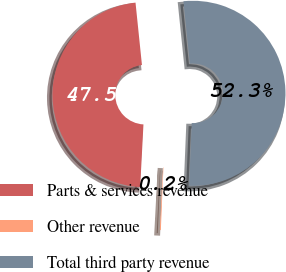Convert chart to OTSL. <chart><loc_0><loc_0><loc_500><loc_500><pie_chart><fcel>Parts & services revenue<fcel>Other revenue<fcel>Total third party revenue<nl><fcel>47.53%<fcel>0.18%<fcel>52.29%<nl></chart> 